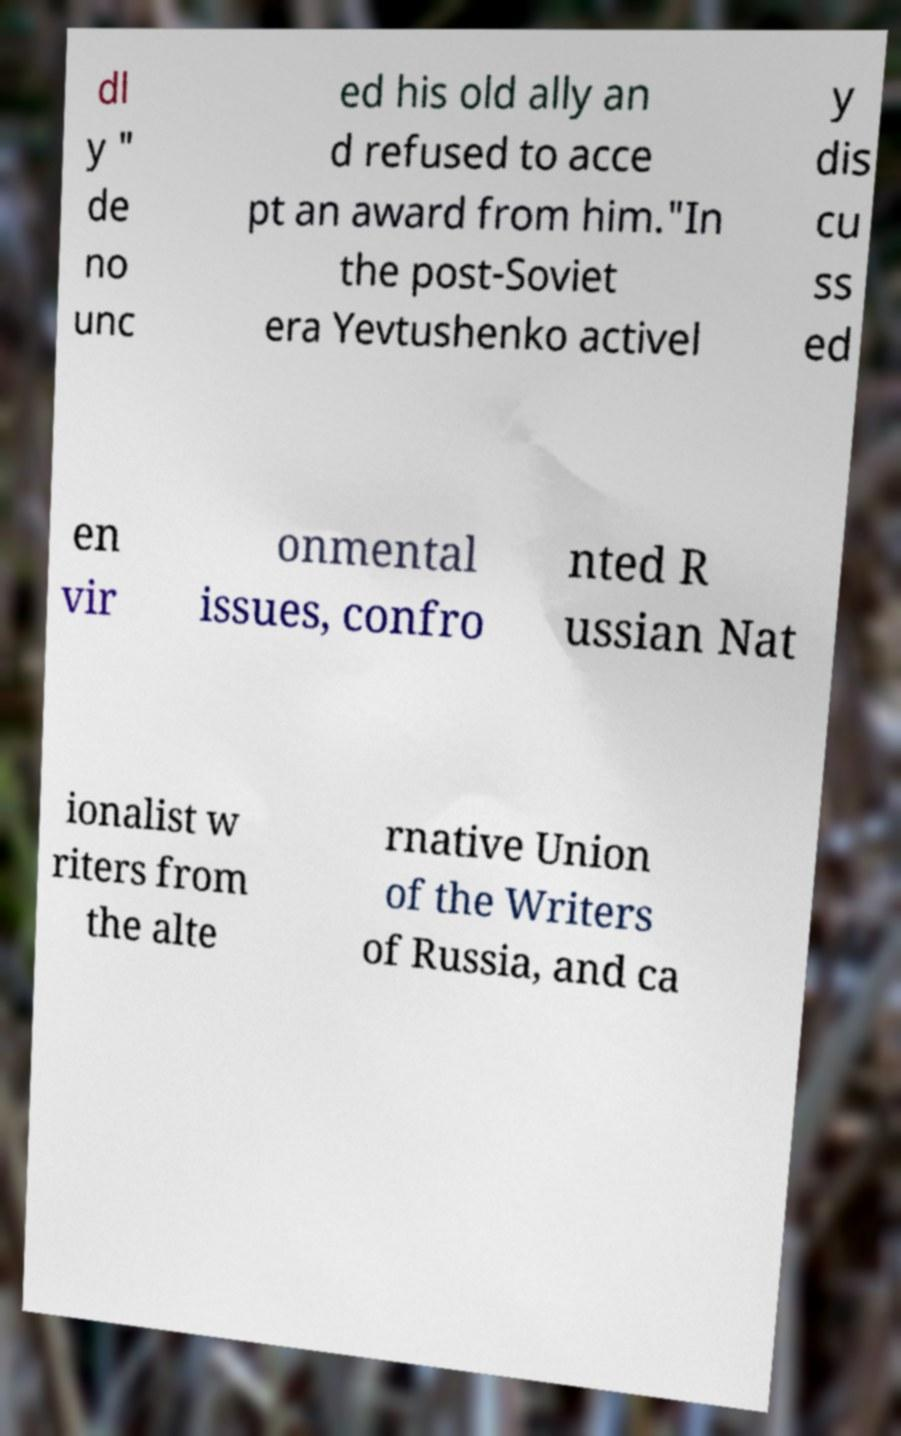What messages or text are displayed in this image? I need them in a readable, typed format. dl y " de no unc ed his old ally an d refused to acce pt an award from him."In the post-Soviet era Yevtushenko activel y dis cu ss ed en vir onmental issues, confro nted R ussian Nat ionalist w riters from the alte rnative Union of the Writers of Russia, and ca 